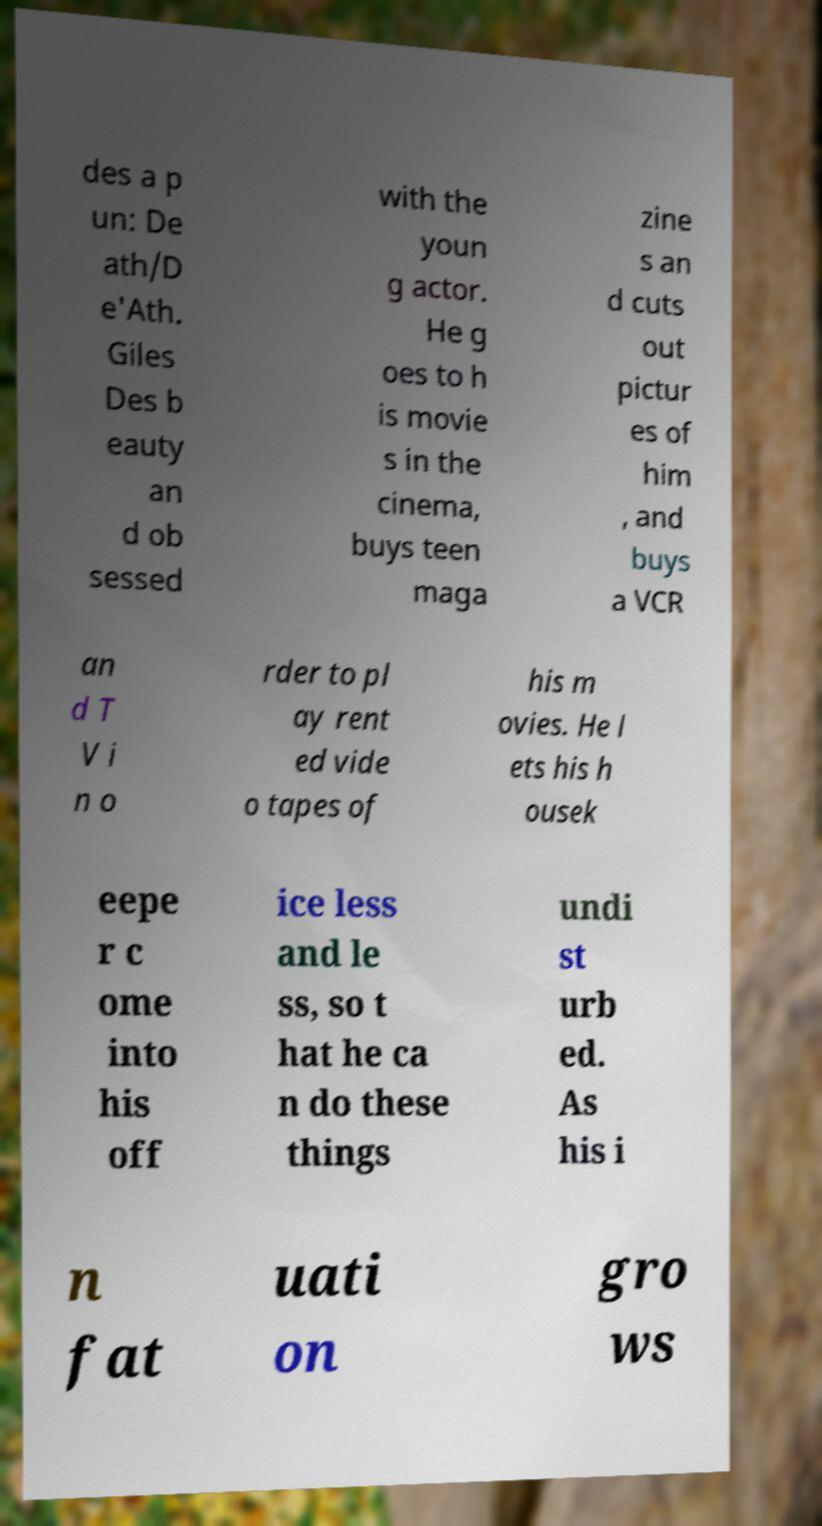For documentation purposes, I need the text within this image transcribed. Could you provide that? des a p un: De ath/D e'Ath. Giles Des b eauty an d ob sessed with the youn g actor. He g oes to h is movie s in the cinema, buys teen maga zine s an d cuts out pictur es of him , and buys a VCR an d T V i n o rder to pl ay rent ed vide o tapes of his m ovies. He l ets his h ousek eepe r c ome into his off ice less and le ss, so t hat he ca n do these things undi st urb ed. As his i n fat uati on gro ws 